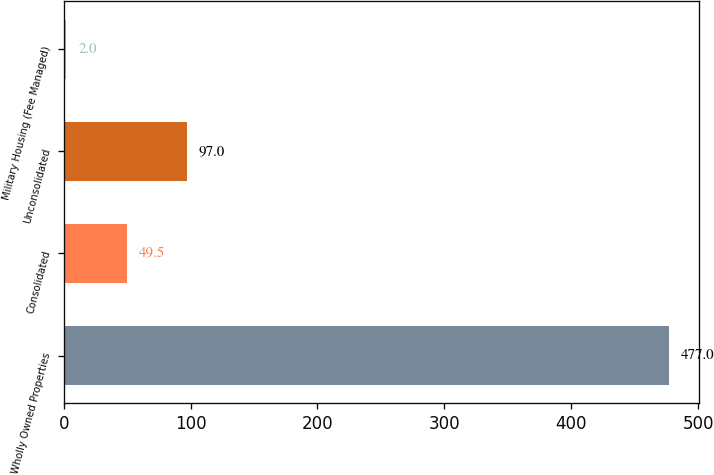<chart> <loc_0><loc_0><loc_500><loc_500><bar_chart><fcel>Wholly Owned Properties<fcel>Consolidated<fcel>Unconsolidated<fcel>Military Housing (Fee Managed)<nl><fcel>477<fcel>49.5<fcel>97<fcel>2<nl></chart> 